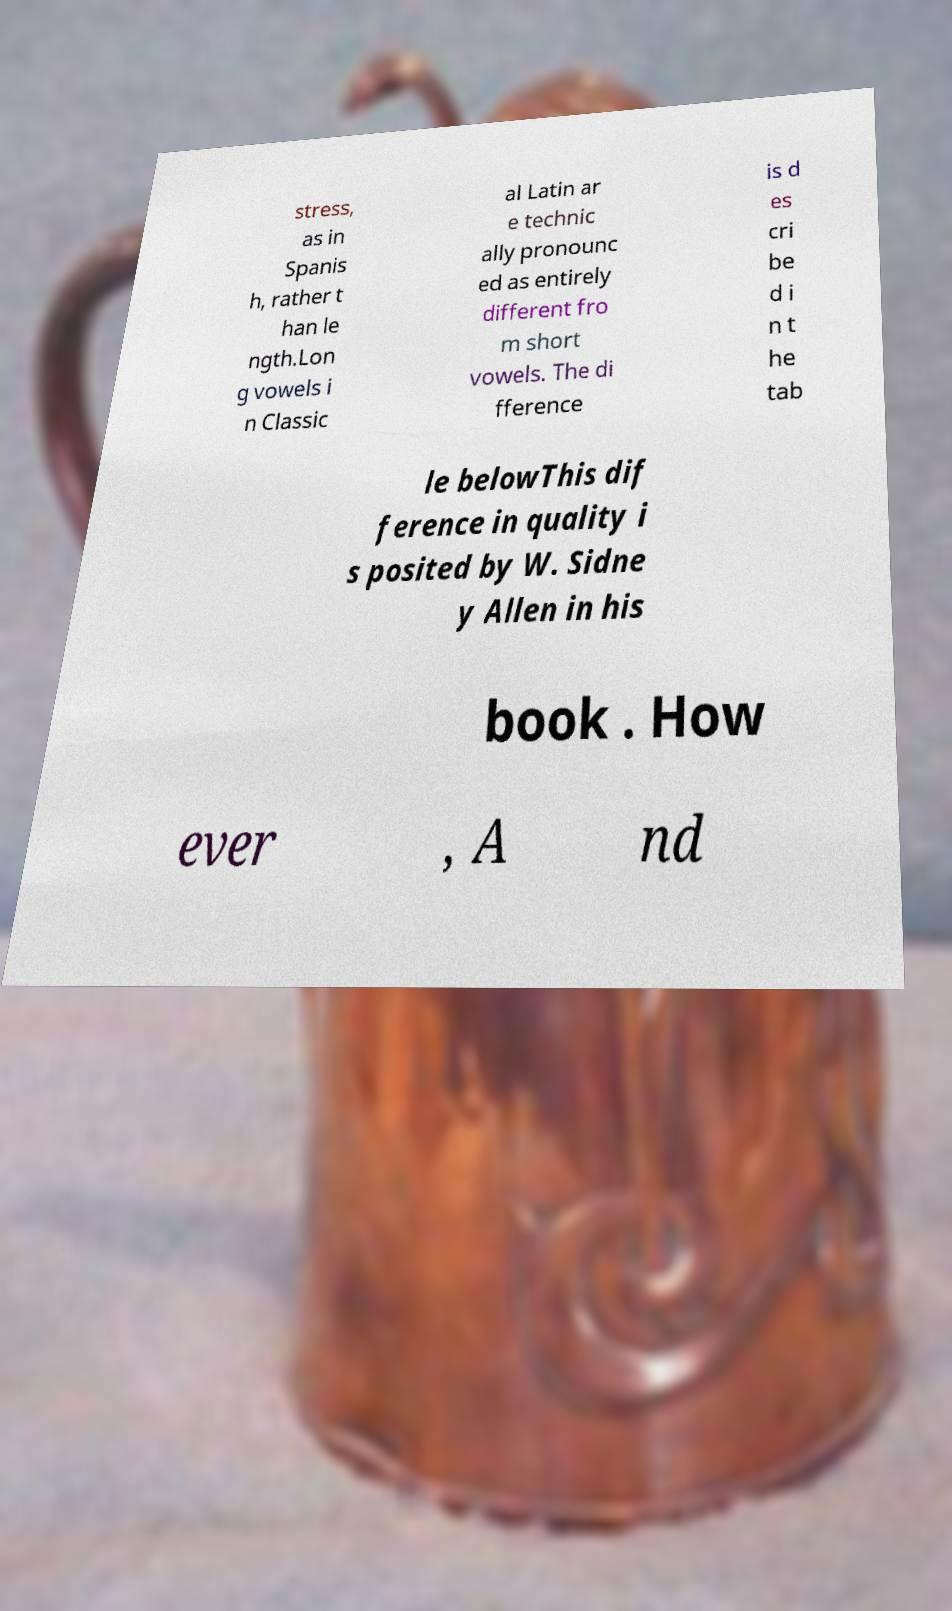Please read and relay the text visible in this image. What does it say? stress, as in Spanis h, rather t han le ngth.Lon g vowels i n Classic al Latin ar e technic ally pronounc ed as entirely different fro m short vowels. The di fference is d es cri be d i n t he tab le belowThis dif ference in quality i s posited by W. Sidne y Allen in his book . How ever , A nd 